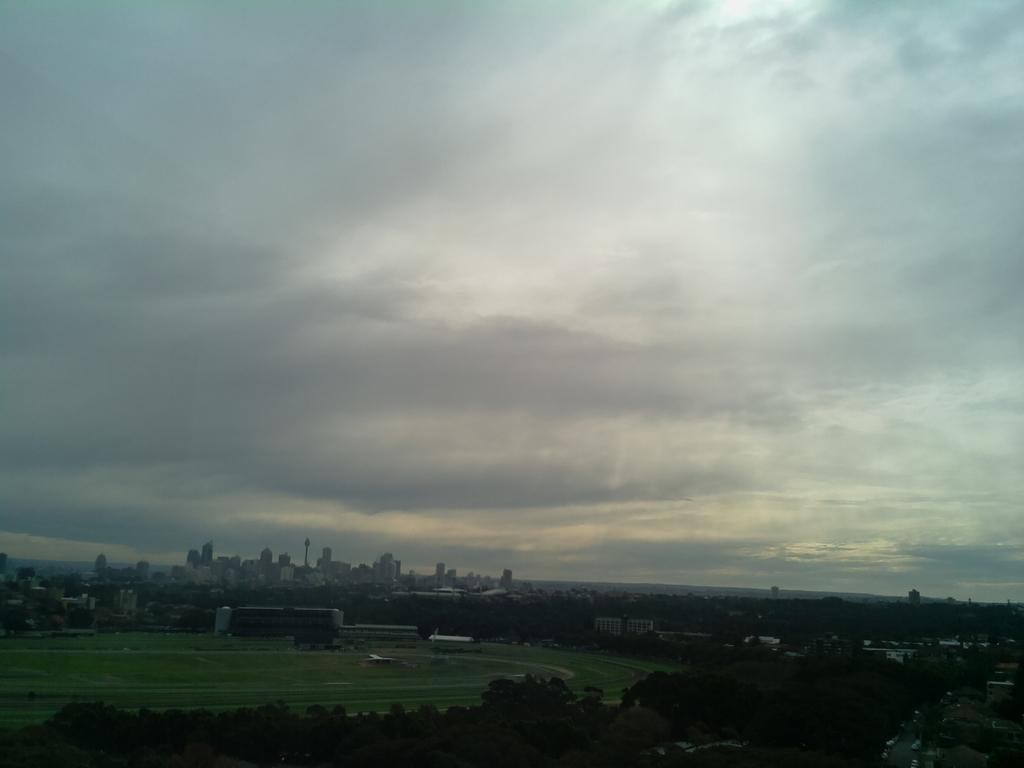How would you summarize this image in a sentence or two? In this image , in the middle we can see a ground at the bottom ,there are many trees at the back there are many buildings and the background is the sky. 